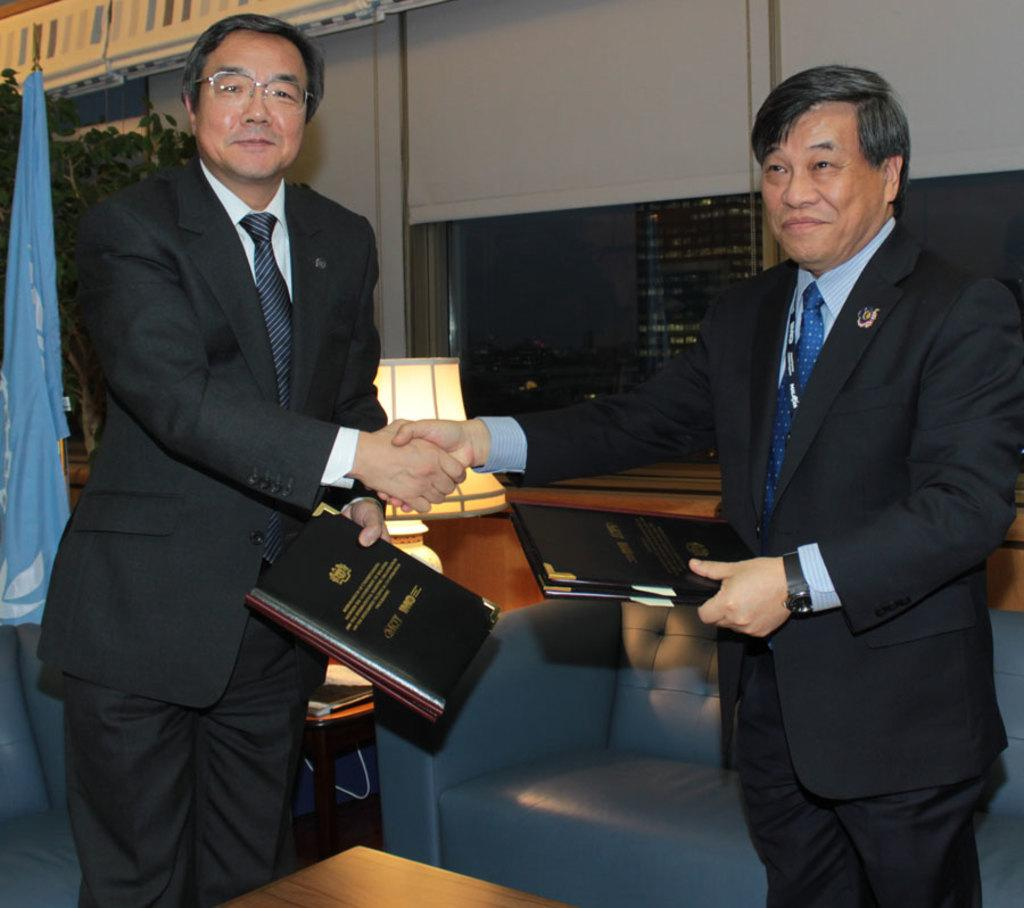How many people are present in the image? There are two people in the image. What is one person doing in the image? One person is holding an object. What type of furniture can be seen in the image? There is a couch in the image. What decorative item is present in the image? There is a flag in the image. What living organism is visible in the image? There is a plant in the image. What architectural feature is present in the image? There is a window in the image. What type of structure is visible in the background of the image? There is a building in the image. What part of the natural environment is visible in the image? The sky is visible in the image. How many babies are crawling on the couch in the image? There are no babies present in the image, and no one is crawling on the couch. What type of trousers is the person wearing in the image? The provided facts do not mention the type of trousers worn by the person in the image. 